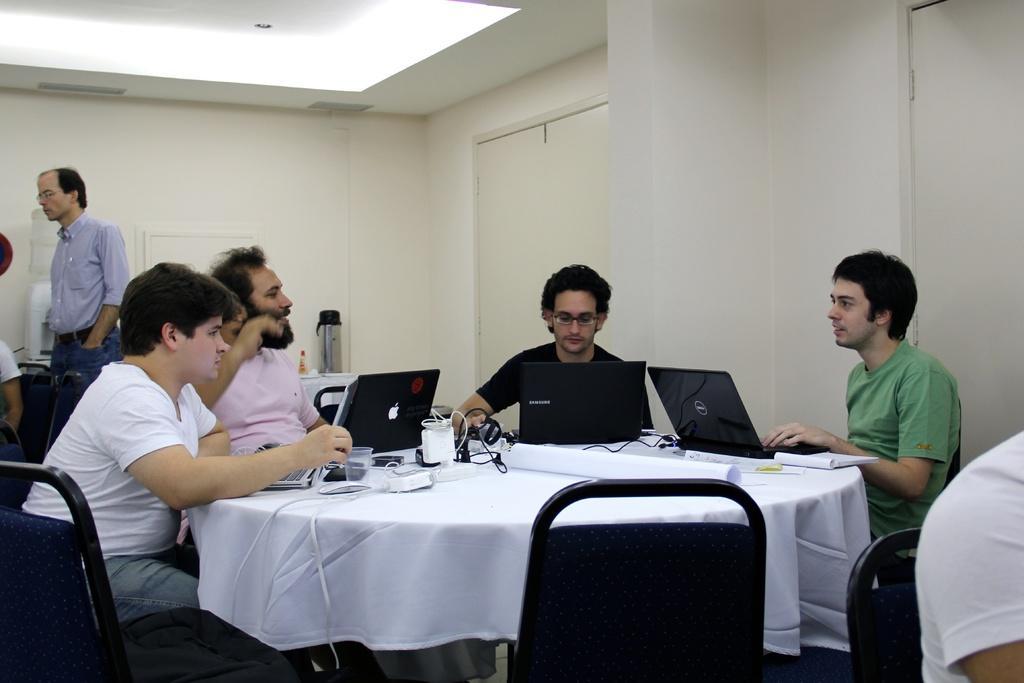Can you describe this image briefly? It is closed room four people are sitting on the chairs and in front of them there is a round table covered with a cloth and the laptops on it and there are empty glasses, behind them there is a white wall and a door and in the left corner of the picture there is a one person standing wearing a blue shirt and jeans, behind him there is a water can and a flask is there on the table behind them, there are two empty chairs. 